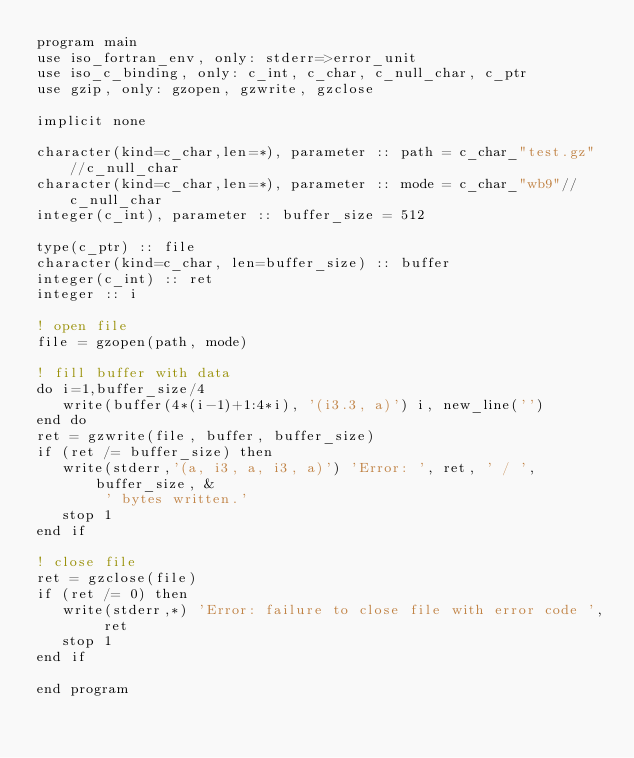<code> <loc_0><loc_0><loc_500><loc_500><_FORTRAN_>program main
use iso_fortran_env, only: stderr=>error_unit
use iso_c_binding, only: c_int, c_char, c_null_char, c_ptr
use gzip, only: gzopen, gzwrite, gzclose

implicit none

character(kind=c_char,len=*), parameter :: path = c_char_"test.gz"//c_null_char
character(kind=c_char,len=*), parameter :: mode = c_char_"wb9"//c_null_char
integer(c_int), parameter :: buffer_size = 512

type(c_ptr) :: file
character(kind=c_char, len=buffer_size) :: buffer
integer(c_int) :: ret
integer :: i

! open file
file = gzopen(path, mode)

! fill buffer with data
do i=1,buffer_size/4
   write(buffer(4*(i-1)+1:4*i), '(i3.3, a)') i, new_line('')
end do
ret = gzwrite(file, buffer, buffer_size)
if (ret /= buffer_size) then
   write(stderr,'(a, i3, a, i3, a)') 'Error: ', ret, ' / ', buffer_size, &
        ' bytes written.'
   stop 1
end if

! close file
ret = gzclose(file)
if (ret /= 0) then
   write(stderr,*) 'Error: failure to close file with error code ', ret
   stop 1
end if

end program
</code> 